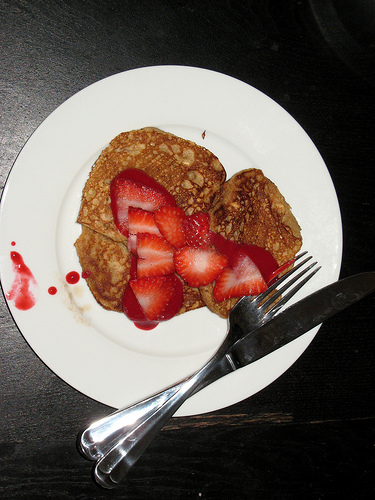<image>
Is the strawberry on the knife? No. The strawberry is not positioned on the knife. They may be near each other, but the strawberry is not supported by or resting on top of the knife. 